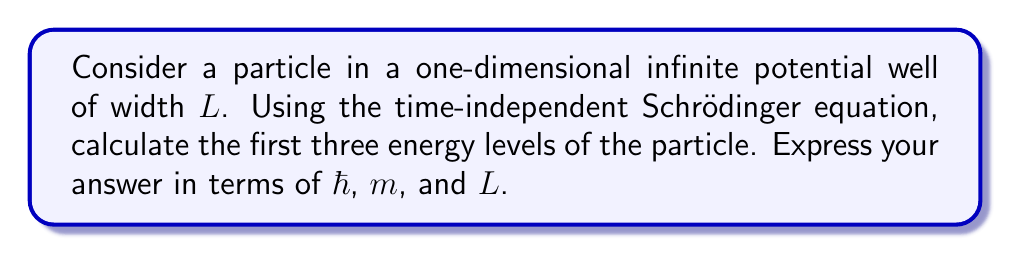Help me with this question. To solve this problem, we'll follow these steps:

1) The time-independent Schrödinger equation for a particle in a one-dimensional potential well is:

   $$-\frac{\hbar^2}{2m}\frac{d^2\psi}{dx^2} = E\psi$$

2) For an infinite potential well, the potential $V(x)$ is:
   
   $$V(x) = \begin{cases} 
   0 & \text{for } 0 < x < L \\
   \infty & \text{otherwise}
   \end{cases}$$

3) The general solution to this equation inside the well is:

   $$\psi(x) = A\sin(kx) + B\cos(kx)$$

   where $k = \sqrt{\frac{2mE}{\hbar^2}}$

4) The boundary conditions for an infinite well are $\psi(0) = \psi(L) = 0$. Applying these:

   At $x = 0$: $\psi(0) = B = 0$
   At $x = L$: $\psi(L) = A\sin(kL) = 0$

5) For the second condition to be true (and $A \neq 0$), we must have:

   $$kL = n\pi$$

   where $n$ is a positive integer.

6) Substituting the expression for $k$:

   $$\sqrt{\frac{2mE}{\hbar^2}}L = n\pi$$

7) Solving for $E$:

   $$E = \frac{n^2\pi^2\hbar^2}{2mL^2}$$

8) This gives us the energy levels. For the first three levels, $n = 1, 2, 3$:

   $$E_1 = \frac{\pi^2\hbar^2}{2mL^2}$$
   $$E_2 = \frac{4\pi^2\hbar^2}{2mL^2}$$
   $$E_3 = \frac{9\pi^2\hbar^2}{2mL^2}$$
Answer: The first three energy levels are:

$E_1 = \frac{\pi^2\hbar^2}{2mL^2}$

$E_2 = \frac{4\pi^2\hbar^2}{2mL^2}$

$E_3 = \frac{9\pi^2\hbar^2}{2mL^2}$ 